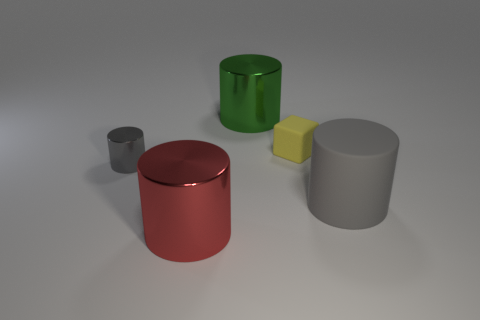Add 1 red metal objects. How many objects exist? 6 Subtract all blue cylinders. Subtract all yellow blocks. How many cylinders are left? 4 Subtract all cylinders. How many objects are left? 1 Subtract all cylinders. Subtract all matte cylinders. How many objects are left? 0 Add 4 big green cylinders. How many big green cylinders are left? 5 Add 2 large red shiny objects. How many large red shiny objects exist? 3 Subtract 0 blue blocks. How many objects are left? 5 